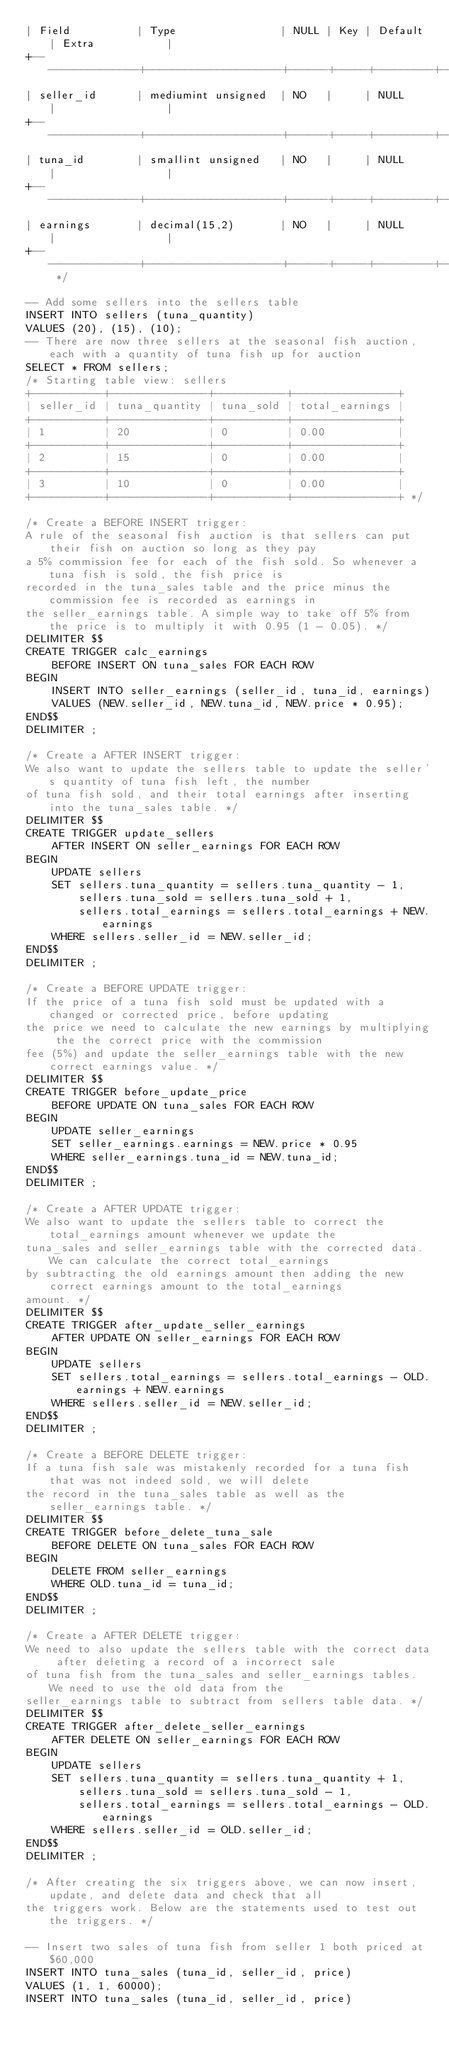Convert code to text. <code><loc_0><loc_0><loc_500><loc_500><_SQL_>| Field          | Type                | NULL | Key | Default | Extra           |
+----------------+---------------------+------+-----+---------+-----------------+
| seller_id	     | mediumint unsigned  | NO   |     | NULL    |                 |
+----------------+---------------------+------+-----+---------+-----------------+
| tuna_id        | smallint unsigned   | NO   |     | NULL    |                 |
+----------------+---------------------+------+-----+---------+-----------------+
| earnings       | decimal(15,2)       | NO   |     | NULL    |                 | 
+----------------+---------------------+------+-----+---------+-----------------+ */

-- Add some sellers into the sellers table
INSERT INTO sellers (tuna_quantity)
VALUES (20), (15), (10);
-- There are now three sellers at the seasonal fish auction, each with a quantity of tuna fish up for auction
SELECT * FROM sellers;
/* Starting table view: sellers
+-----------+---------------+-----------+----------------+
| seller_id | tuna_quantity | tuna_sold | total_earnings |
+-----------+---------------+-----------+----------------+
| 1         | 20            | 0         | 0.00           |
+-----------+---------------+-----------+----------------+
| 2         | 15            | 0         | 0.00           |
+-----------+---------------+-----------+----------------+
| 3         | 10            | 0         | 0.00           |
+-----------+---------------+-----------+----------------+ */

/* Create a BEFORE INSERT trigger:
A rule of the seasonal fish auction is that sellers can put their fish on auction so long as they pay
a 5% commission fee for each of the fish sold. So whenever a tuna fish is sold, the fish price is
recorded in the tuna_sales table and the price minus the commission fee is recorded as earnings in
the seller_earnings table. A simple way to take off 5% from the price is to multiply it with 0.95 (1 - 0.05). */
DELIMITER $$
CREATE TRIGGER calc_earnings
    BEFORE INSERT ON tuna_sales FOR EACH ROW
BEGIN
    INSERT INTO seller_earnings (seller_id, tuna_id, earnings)
    VALUES (NEW.seller_id, NEW.tuna_id, NEW.price * 0.95);
END$$
DELIMITER ;

/* Create a AFTER INSERT trigger:
We also want to update the sellers table to update the seller's quantity of tuna fish left, the number
of tuna fish sold, and their total earnings after inserting into the tuna_sales table. */
DELIMITER $$
CREATE TRIGGER update_sellers
    AFTER INSERT ON seller_earnings FOR EACH ROW
BEGIN
    UPDATE sellers
    SET sellers.tuna_quantity = sellers.tuna_quantity - 1,
        sellers.tuna_sold = sellers.tuna_sold + 1,
        sellers.total_earnings = sellers.total_earnings + NEW.earnings
    WHERE sellers.seller_id = NEW.seller_id;   
END$$
DELIMITER ;

/* Create a BEFORE UPDATE trigger:
If the price of a tuna fish sold must be updated with a changed or corrected price, before updating
the price we need to calculate the new earnings by multiplying the the correct price with the commission
fee (5%) and update the seller_earnings table with the new correct earnings value. */
DELIMITER $$
CREATE TRIGGER before_update_price
    BEFORE UPDATE ON tuna_sales FOR EACH ROW
BEGIN
    UPDATE seller_earnings
    SET seller_earnings.earnings = NEW.price * 0.95
    WHERE seller_earnings.tuna_id = NEW.tuna_id;
END$$
DELIMITER ;

/* Create a AFTER UPDATE trigger:
We also want to update the sellers table to correct the total_earnings amount whenever we update the
tuna_sales and seller_earnings table with the corrected data. We can calculate the correct total_earnings
by subtracting the old earnings amount then adding the new correct earnings amount to the total_earnings
amount. */
DELIMITER $$
CREATE TRIGGER after_update_seller_earnings
    AFTER UPDATE ON seller_earnings FOR EACH ROW
BEGIN
    UPDATE sellers
    SET sellers.total_earnings = sellers.total_earnings - OLD.earnings + NEW.earnings
    WHERE sellers.seller_id = NEW.seller_id;
END$$    
DELIMITER ;

/* Create a BEFORE DELETE trigger:
If a tuna fish sale was mistakenly recorded for a tuna fish that was not indeed sold, we will delete
the record in the tuna_sales table as well as the seller_earnings table. */
DELIMITER $$
CREATE TRIGGER before_delete_tuna_sale
    BEFORE DELETE ON tuna_sales FOR EACH ROW
BEGIN
    DELETE FROM seller_earnings
    WHERE OLD.tuna_id = tuna_id;
END$$
DELIMITER ;

/* Create a AFTER DELETE trigger:
We need to also update the sellers table with the correct data after deleting a record of a incorrect sale
of tuna fish from the tuna_sales and seller_earnings tables. We need to use the old data from the
seller_earnings table to subtract from sellers table data. */
DELIMITER $$
CREATE TRIGGER after_delete_seller_earnings
    AFTER DELETE ON seller_earnings FOR EACH ROW
BEGIN
    UPDATE sellers
    SET sellers.tuna_quantity = sellers.tuna_quantity + 1,
        sellers.tuna_sold = sellers.tuna_sold - 1,
        sellers.total_earnings = sellers.total_earnings - OLD.earnings
    WHERE sellers.seller_id = OLD.seller_id;
END$$
DELIMITER ;

/* After creating the six triggers above, we can now insert, update, and delete data and check that all
the triggers work. Below are the statements used to test out the triggers. */

-- Insert two sales of tuna fish from seller 1 both priced at $60,000
INSERT INTO tuna_sales (tuna_id, seller_id, price)
VALUES (1, 1, 60000);
INSERT INTO tuna_sales (tuna_id, seller_id, price)</code> 